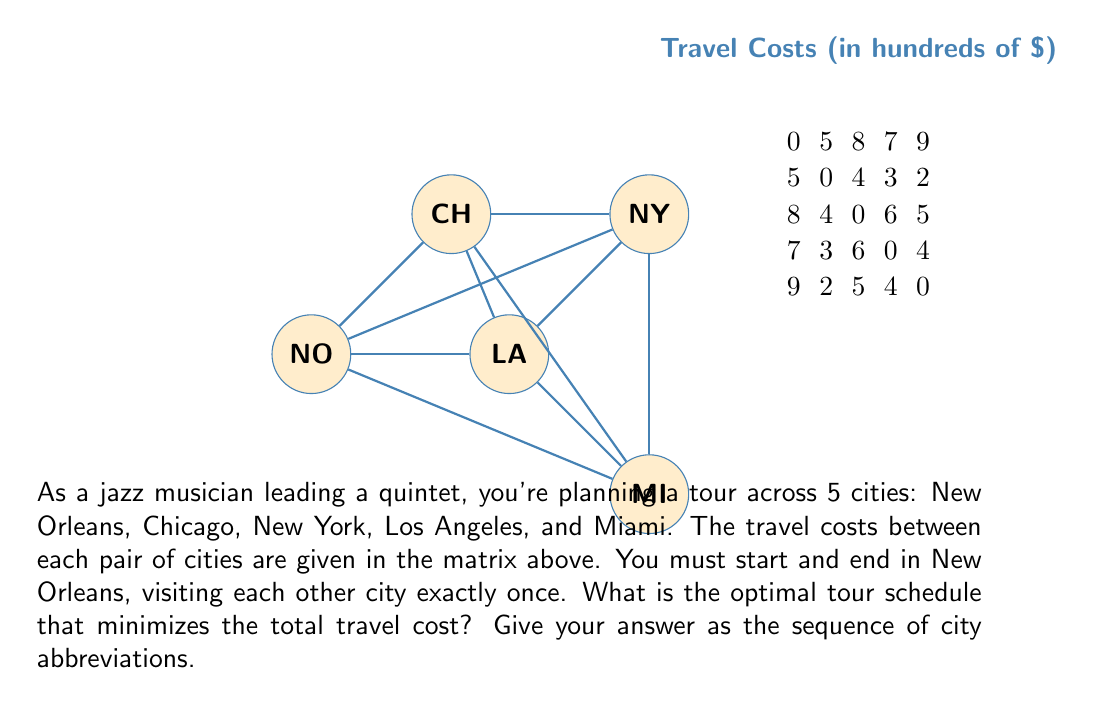Can you answer this question? This problem is an instance of the Traveling Salesman Problem (TSP), which can be solved using various methods. For this small instance, we can use the brute-force approach to find the optimal solution.

Steps:
1) List all possible tours starting and ending in New Orleans (NO):
   NO-CH-NY-LA-MI-NO
   NO-CH-NY-MI-LA-NO
   NO-CH-LA-NY-MI-NO
   NO-CH-LA-MI-NY-NO
   NO-CH-MI-NY-LA-NO
   NO-CH-MI-LA-NY-NO
   ...and so on (24 total permutations)

2) Calculate the cost for each tour:
   NO-CH-NY-LA-MI-NO: 5 + 4 + 6 + 4 + 9 = 28
   NO-CH-NY-MI-LA-NO: 5 + 4 + 5 + 4 + 7 = 25
   NO-CH-LA-NY-MI-NO: 5 + 3 + 6 + 5 + 9 = 28
   NO-CH-LA-MI-NY-NO: 5 + 3 + 4 + 5 + 8 = 25
   NO-CH-MI-NY-LA-NO: 5 + 2 + 5 + 6 + 7 = 25
   NO-CH-MI-LA-NY-NO: 5 + 2 + 4 + 6 + 8 = 25
   ...and so on

3) Identify the tour with the minimum cost:
   The optimal tour is NO-CH-MI-LA-NY-NO with a total cost of 25 (hundred dollars).

This solution balances the trade-off between longer individual legs (like NO-NY) and the overall efficiency of the route, much like how jazz musicians balance composed sections with improvisation to create a cohesive performance.
Answer: NO-CH-MI-LA-NY-NO 